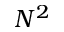<formula> <loc_0><loc_0><loc_500><loc_500>N ^ { 2 }</formula> 